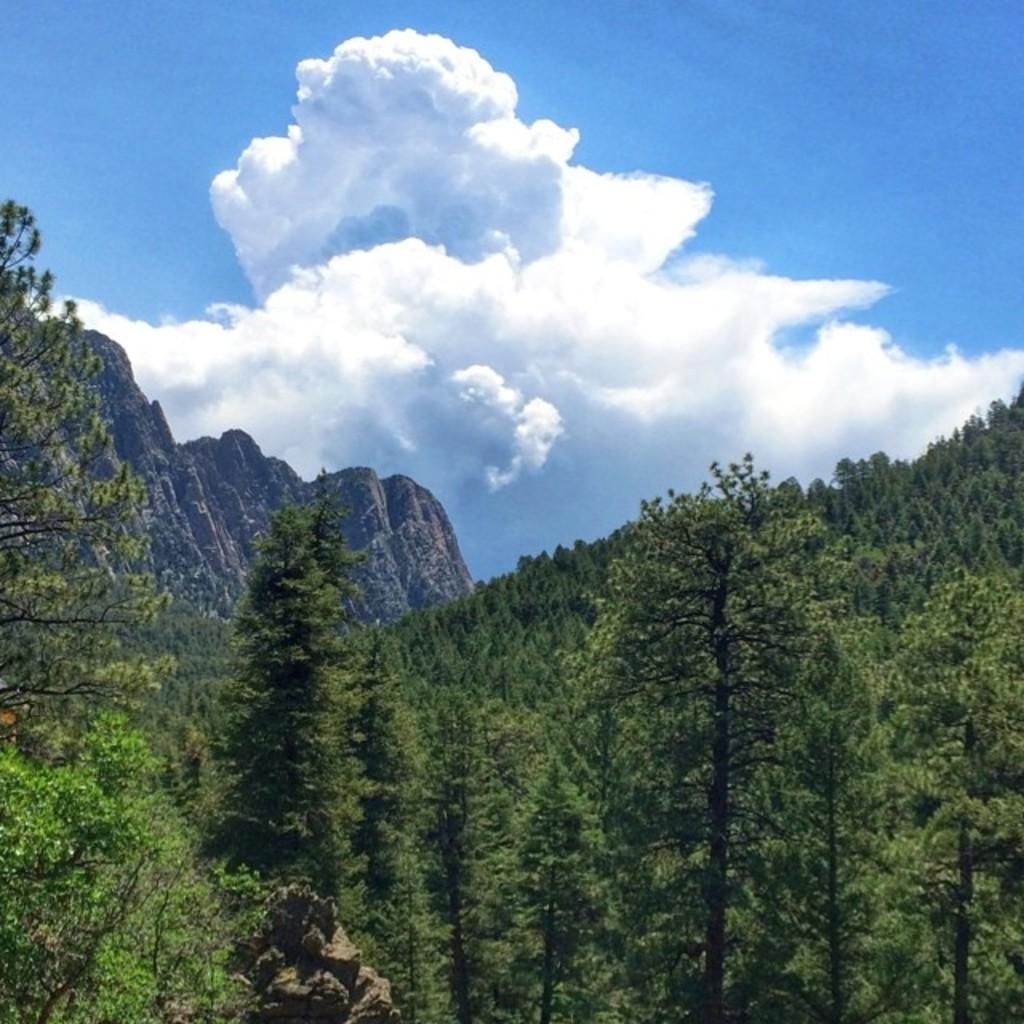What type of vegetation can be seen in the image? There are trees in the image. What geographical feature is located in the middle of the image? There is a hill in the middle of the image. What is visible in the sky in the image? There are clouds in the sky. Where is the library located in the image? There is no library present in the image. What type of place is depicted in the image? The image does not depict a specific place; it shows trees, a hill, and clouds. Can you tell me if there was an earthquake in the image? There is no indication of an earthquake in the image; it shows a natural landscape with trees, a hill, and clouds. 